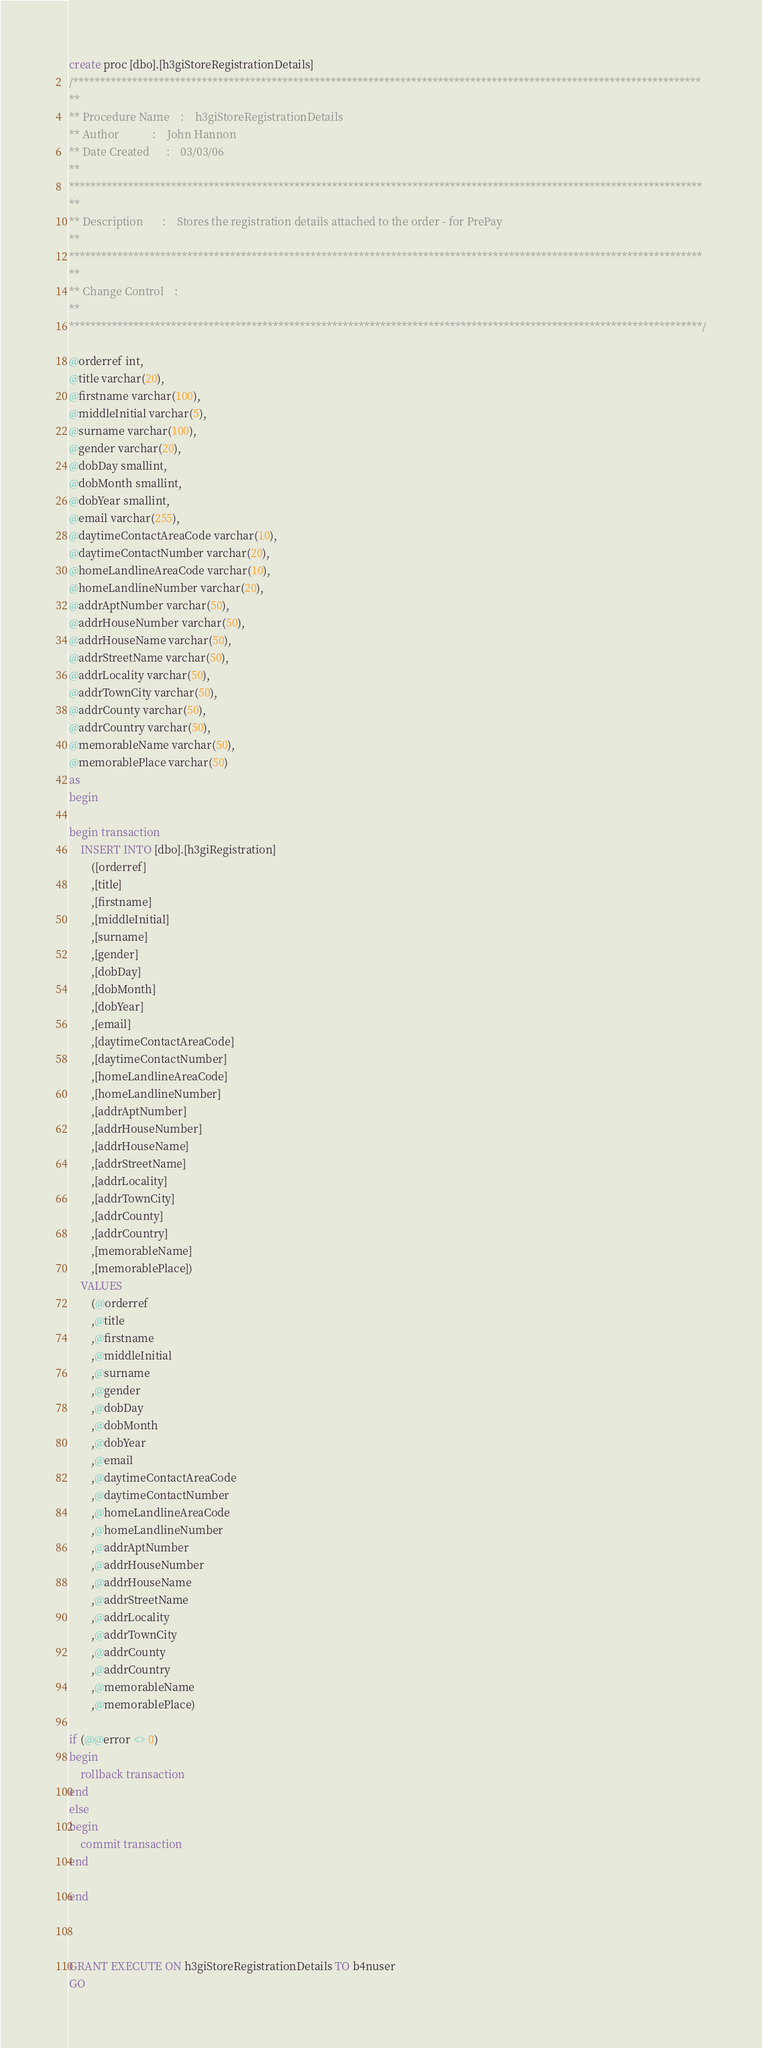<code> <loc_0><loc_0><loc_500><loc_500><_SQL_>

create proc [dbo].[h3giStoreRegistrationDetails]
/*********************************************************************************************************************
**                                                                                                              
** Procedure Name    :    h3giStoreRegistrationDetails
** Author            :    John Hannon
** Date Created      :    03/03/06
**                         
**********************************************************************************************************************
**                   
** Description       :    Stores the registration details attached to the order - for PrePay
**                         
**********************************************************************************************************************
**                                              
** Change Control    :    
**                              
**********************************************************************************************************************/

@orderref int,
@title varchar(20),
@firstname varchar(100),
@middleInitial varchar(5),
@surname varchar(100),
@gender varchar(20),
@dobDay smallint,
@dobMonth smallint,
@dobYear smallint,
@email varchar(255),
@daytimeContactAreaCode varchar(10),
@daytimeContactNumber varchar(20),
@homeLandlineAreaCode varchar(10),
@homeLandlineNumber varchar(20),
@addrAptNumber varchar(50),
@addrHouseNumber varchar(50),
@addrHouseName varchar(50),
@addrStreetName varchar(50),
@addrLocality varchar(50),
@addrTownCity varchar(50),
@addrCounty varchar(50),
@addrCountry varchar(50),
@memorableName varchar(50),
@memorablePlace varchar(50)
as
begin

begin transaction
	INSERT INTO [dbo].[h3giRegistration]
		([orderref]
		,[title]
		,[firstname]
		,[middleInitial]
		,[surname]
		,[gender]
		,[dobDay]
		,[dobMonth]
		,[dobYear]
		,[email] 
		,[daytimeContactAreaCode] 
		,[daytimeContactNumber] 
		,[homeLandlineAreaCode] 
		,[homeLandlineNumber] 
		,[addrAptNumber]
		,[addrHouseNumber] 
		,[addrHouseName]
		,[addrStreetName] 
		,[addrLocality] 
		,[addrTownCity] 
		,[addrCounty] 
		,[addrCountry] 
		,[memorableName] 
		,[memorablePlace])
	VALUES
		(@orderref
		,@title
		,@firstname
		,@middleInitial
		,@surname
		,@gender
		,@dobDay
		,@dobMonth
		,@dobYear
		,@email
		,@daytimeContactAreaCode
		,@daytimeContactNumber
		,@homeLandlineAreaCode
		,@homeLandlineNumber
		,@addrAptNumber
		,@addrHouseNumber
		,@addrHouseName
		,@addrStreetName
		,@addrLocality
		,@addrTownCity
		,@addrCounty
		,@addrCountry
		,@memorableName
		,@memorablePlace)

if (@@error <> 0)
begin
	rollback transaction
end
else
begin
	commit transaction
end

end



GRANT EXECUTE ON h3giStoreRegistrationDetails TO b4nuser
GO
</code> 